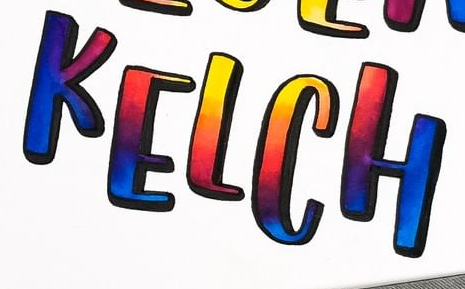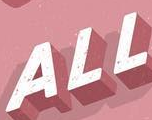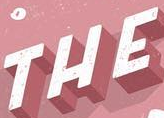What text is displayed in these images sequentially, separated by a semicolon? KELCH; ALL; THE 